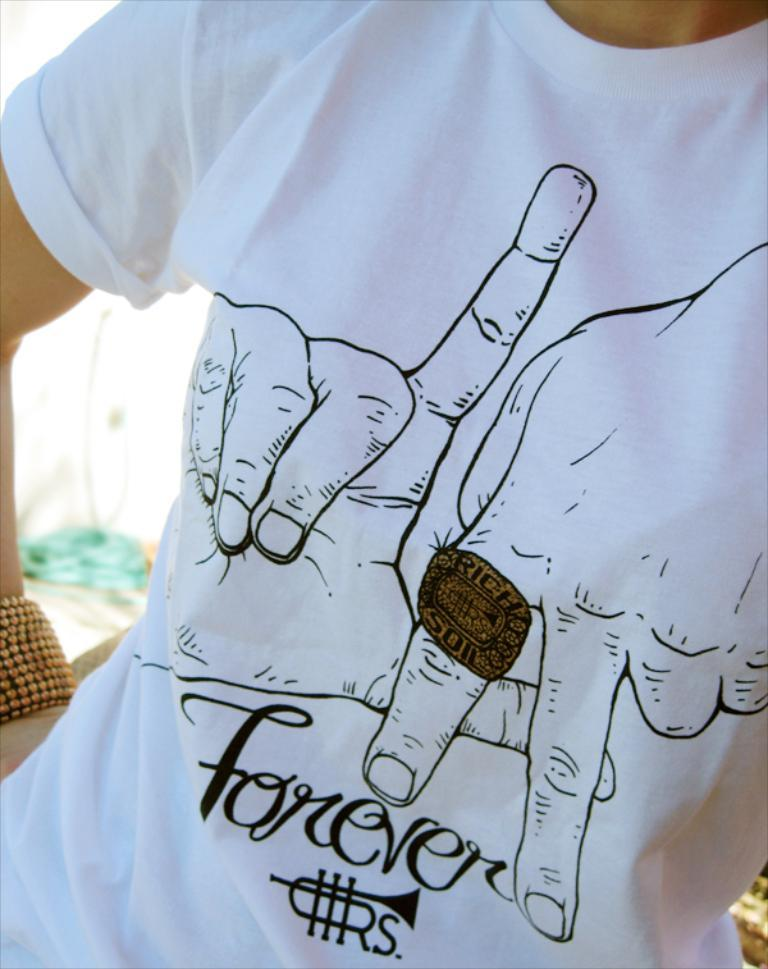Who or what is the main subject in the image? There is a person in the image. What is the person wearing in the image? The person is wearing a white shirt. Can you describe the design on the shirt? The shirt has text printed on it and also has hands with a ring printed on it. What type of mist can be seen surrounding the person in the image? There is no mist present in the image; it features a person wearing a shirt with text and hands with a ring printed on it. What kind of wine is the person holding in the image? There is no wine present in the image; the person is wearing a shirt with text and hands with a ring printed on it. 